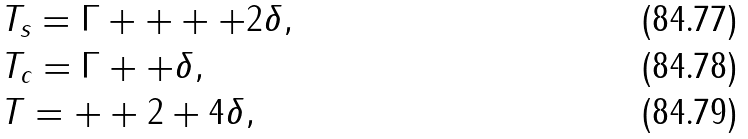<formula> <loc_0><loc_0><loc_500><loc_500>& T _ { s } = \Gamma + + + + 2 \delta , \\ & T _ { c } = \Gamma + + \delta , \\ & T = + + 2 + 4 \delta ,</formula> 